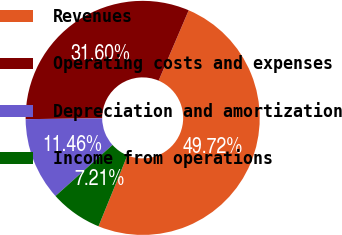<chart> <loc_0><loc_0><loc_500><loc_500><pie_chart><fcel>Revenues<fcel>Operating costs and expenses<fcel>Depreciation and amortization<fcel>Income from operations<nl><fcel>49.72%<fcel>31.6%<fcel>11.46%<fcel>7.21%<nl></chart> 